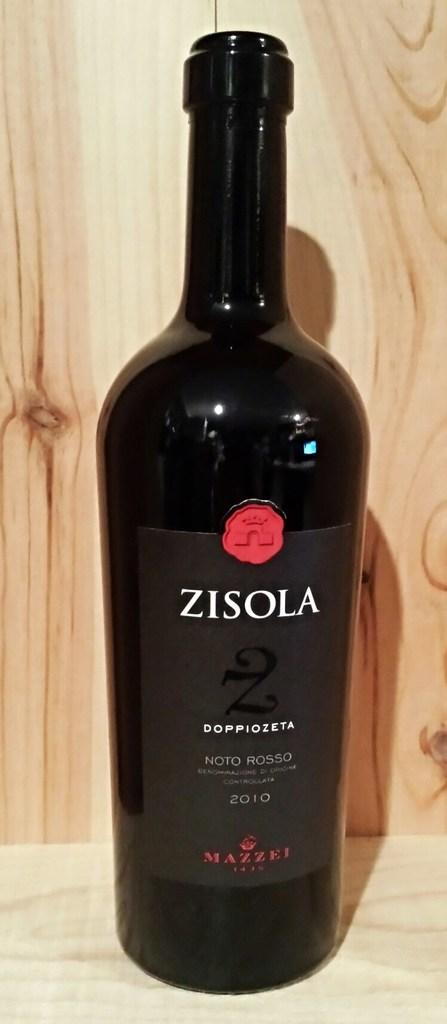<image>
Summarize the visual content of the image. A bottle of Zisola Doppiozeta has a red wax seal on the bottle. 